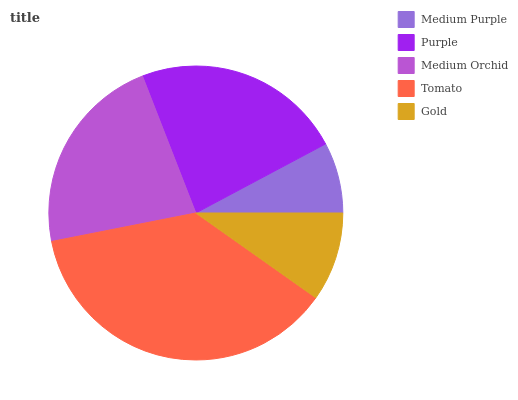Is Medium Purple the minimum?
Answer yes or no. Yes. Is Tomato the maximum?
Answer yes or no. Yes. Is Purple the minimum?
Answer yes or no. No. Is Purple the maximum?
Answer yes or no. No. Is Purple greater than Medium Purple?
Answer yes or no. Yes. Is Medium Purple less than Purple?
Answer yes or no. Yes. Is Medium Purple greater than Purple?
Answer yes or no. No. Is Purple less than Medium Purple?
Answer yes or no. No. Is Medium Orchid the high median?
Answer yes or no. Yes. Is Medium Orchid the low median?
Answer yes or no. Yes. Is Gold the high median?
Answer yes or no. No. Is Gold the low median?
Answer yes or no. No. 